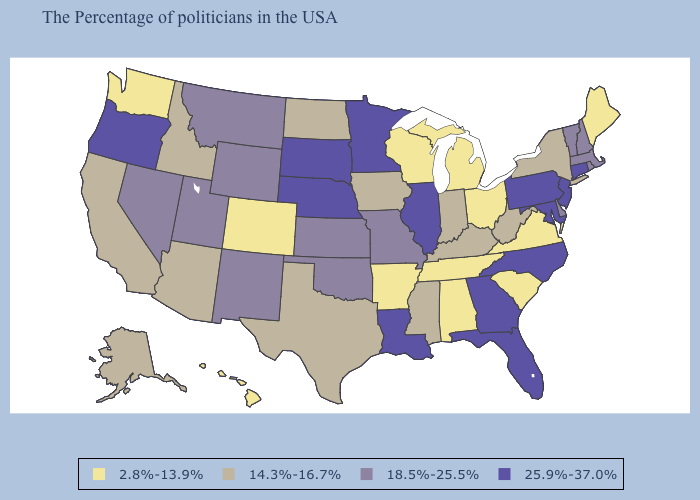What is the lowest value in the West?
Give a very brief answer. 2.8%-13.9%. Does Massachusetts have a lower value than Illinois?
Give a very brief answer. Yes. What is the value of Illinois?
Give a very brief answer. 25.9%-37.0%. Does Arkansas have the lowest value in the South?
Write a very short answer. Yes. What is the value of Indiana?
Answer briefly. 14.3%-16.7%. Does Nebraska have the highest value in the USA?
Write a very short answer. Yes. Does Illinois have the lowest value in the USA?
Keep it brief. No. Name the states that have a value in the range 18.5%-25.5%?
Be succinct. Massachusetts, Rhode Island, New Hampshire, Vermont, Delaware, Missouri, Kansas, Oklahoma, Wyoming, New Mexico, Utah, Montana, Nevada. What is the value of Vermont?
Be succinct. 18.5%-25.5%. Does Oregon have the same value as Colorado?
Answer briefly. No. Among the states that border Texas , which have the highest value?
Give a very brief answer. Louisiana. What is the highest value in the USA?
Keep it brief. 25.9%-37.0%. Which states have the highest value in the USA?
Give a very brief answer. Connecticut, New Jersey, Maryland, Pennsylvania, North Carolina, Florida, Georgia, Illinois, Louisiana, Minnesota, Nebraska, South Dakota, Oregon. What is the value of North Carolina?
Be succinct. 25.9%-37.0%. What is the highest value in the USA?
Write a very short answer. 25.9%-37.0%. 